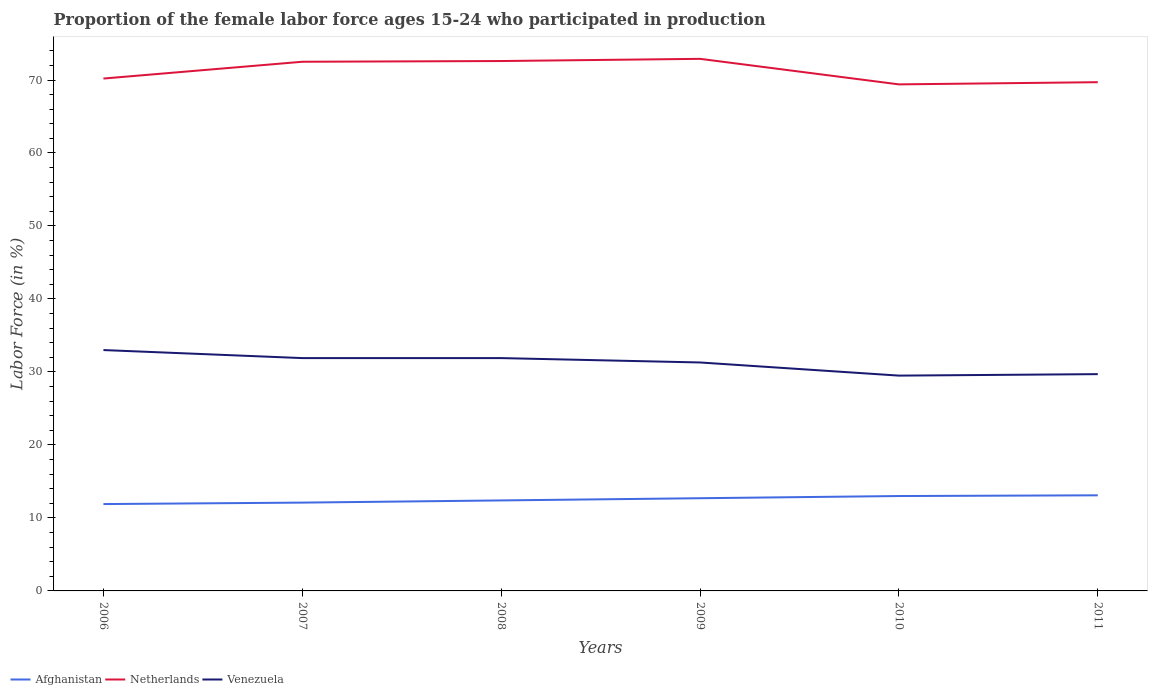Does the line corresponding to Netherlands intersect with the line corresponding to Afghanistan?
Give a very brief answer. No. Is the number of lines equal to the number of legend labels?
Offer a terse response. Yes. Across all years, what is the maximum proportion of the female labor force who participated in production in Venezuela?
Ensure brevity in your answer.  29.5. In which year was the proportion of the female labor force who participated in production in Netherlands maximum?
Offer a terse response. 2010. What is the total proportion of the female labor force who participated in production in Venezuela in the graph?
Your answer should be compact. 3.3. What is the difference between the highest and the second highest proportion of the female labor force who participated in production in Afghanistan?
Your answer should be very brief. 1.2. What is the difference between the highest and the lowest proportion of the female labor force who participated in production in Venezuela?
Your answer should be very brief. 4. How many lines are there?
Your response must be concise. 3. What is the difference between two consecutive major ticks on the Y-axis?
Make the answer very short. 10. Are the values on the major ticks of Y-axis written in scientific E-notation?
Offer a very short reply. No. What is the title of the graph?
Provide a succinct answer. Proportion of the female labor force ages 15-24 who participated in production. Does "Dominica" appear as one of the legend labels in the graph?
Make the answer very short. No. What is the Labor Force (in %) in Afghanistan in 2006?
Ensure brevity in your answer.  11.9. What is the Labor Force (in %) in Netherlands in 2006?
Offer a terse response. 70.2. What is the Labor Force (in %) of Afghanistan in 2007?
Your response must be concise. 12.1. What is the Labor Force (in %) of Netherlands in 2007?
Your answer should be compact. 72.5. What is the Labor Force (in %) in Venezuela in 2007?
Ensure brevity in your answer.  31.9. What is the Labor Force (in %) in Afghanistan in 2008?
Offer a terse response. 12.4. What is the Labor Force (in %) in Netherlands in 2008?
Make the answer very short. 72.6. What is the Labor Force (in %) of Venezuela in 2008?
Give a very brief answer. 31.9. What is the Labor Force (in %) of Afghanistan in 2009?
Keep it short and to the point. 12.7. What is the Labor Force (in %) in Netherlands in 2009?
Offer a terse response. 72.9. What is the Labor Force (in %) in Venezuela in 2009?
Your answer should be compact. 31.3. What is the Labor Force (in %) in Netherlands in 2010?
Your answer should be compact. 69.4. What is the Labor Force (in %) in Venezuela in 2010?
Your answer should be compact. 29.5. What is the Labor Force (in %) of Afghanistan in 2011?
Your response must be concise. 13.1. What is the Labor Force (in %) in Netherlands in 2011?
Keep it short and to the point. 69.7. What is the Labor Force (in %) of Venezuela in 2011?
Ensure brevity in your answer.  29.7. Across all years, what is the maximum Labor Force (in %) in Afghanistan?
Offer a very short reply. 13.1. Across all years, what is the maximum Labor Force (in %) in Netherlands?
Offer a terse response. 72.9. Across all years, what is the minimum Labor Force (in %) of Afghanistan?
Your response must be concise. 11.9. Across all years, what is the minimum Labor Force (in %) of Netherlands?
Make the answer very short. 69.4. Across all years, what is the minimum Labor Force (in %) in Venezuela?
Provide a succinct answer. 29.5. What is the total Labor Force (in %) of Afghanistan in the graph?
Provide a succinct answer. 75.2. What is the total Labor Force (in %) in Netherlands in the graph?
Give a very brief answer. 427.3. What is the total Labor Force (in %) of Venezuela in the graph?
Give a very brief answer. 187.3. What is the difference between the Labor Force (in %) in Afghanistan in 2006 and that in 2007?
Your response must be concise. -0.2. What is the difference between the Labor Force (in %) in Netherlands in 2006 and that in 2007?
Keep it short and to the point. -2.3. What is the difference between the Labor Force (in %) in Venezuela in 2006 and that in 2007?
Give a very brief answer. 1.1. What is the difference between the Labor Force (in %) of Afghanistan in 2006 and that in 2008?
Keep it short and to the point. -0.5. What is the difference between the Labor Force (in %) in Netherlands in 2006 and that in 2008?
Make the answer very short. -2.4. What is the difference between the Labor Force (in %) of Venezuela in 2006 and that in 2008?
Make the answer very short. 1.1. What is the difference between the Labor Force (in %) of Afghanistan in 2006 and that in 2009?
Provide a succinct answer. -0.8. What is the difference between the Labor Force (in %) of Netherlands in 2006 and that in 2009?
Offer a very short reply. -2.7. What is the difference between the Labor Force (in %) in Afghanistan in 2006 and that in 2010?
Your answer should be very brief. -1.1. What is the difference between the Labor Force (in %) in Afghanistan in 2006 and that in 2011?
Your response must be concise. -1.2. What is the difference between the Labor Force (in %) of Netherlands in 2007 and that in 2008?
Provide a short and direct response. -0.1. What is the difference between the Labor Force (in %) of Afghanistan in 2007 and that in 2009?
Offer a very short reply. -0.6. What is the difference between the Labor Force (in %) in Netherlands in 2007 and that in 2009?
Give a very brief answer. -0.4. What is the difference between the Labor Force (in %) in Venezuela in 2007 and that in 2009?
Ensure brevity in your answer.  0.6. What is the difference between the Labor Force (in %) in Netherlands in 2007 and that in 2010?
Ensure brevity in your answer.  3.1. What is the difference between the Labor Force (in %) of Netherlands in 2007 and that in 2011?
Ensure brevity in your answer.  2.8. What is the difference between the Labor Force (in %) in Netherlands in 2008 and that in 2010?
Your response must be concise. 3.2. What is the difference between the Labor Force (in %) of Venezuela in 2008 and that in 2010?
Offer a terse response. 2.4. What is the difference between the Labor Force (in %) in Afghanistan in 2008 and that in 2011?
Keep it short and to the point. -0.7. What is the difference between the Labor Force (in %) of Netherlands in 2008 and that in 2011?
Your answer should be very brief. 2.9. What is the difference between the Labor Force (in %) in Afghanistan in 2009 and that in 2010?
Provide a short and direct response. -0.3. What is the difference between the Labor Force (in %) in Netherlands in 2009 and that in 2011?
Your answer should be very brief. 3.2. What is the difference between the Labor Force (in %) of Venezuela in 2009 and that in 2011?
Give a very brief answer. 1.6. What is the difference between the Labor Force (in %) in Afghanistan in 2010 and that in 2011?
Offer a very short reply. -0.1. What is the difference between the Labor Force (in %) of Afghanistan in 2006 and the Labor Force (in %) of Netherlands in 2007?
Your answer should be compact. -60.6. What is the difference between the Labor Force (in %) of Afghanistan in 2006 and the Labor Force (in %) of Venezuela in 2007?
Your response must be concise. -20. What is the difference between the Labor Force (in %) of Netherlands in 2006 and the Labor Force (in %) of Venezuela in 2007?
Offer a very short reply. 38.3. What is the difference between the Labor Force (in %) in Afghanistan in 2006 and the Labor Force (in %) in Netherlands in 2008?
Give a very brief answer. -60.7. What is the difference between the Labor Force (in %) of Netherlands in 2006 and the Labor Force (in %) of Venezuela in 2008?
Offer a very short reply. 38.3. What is the difference between the Labor Force (in %) of Afghanistan in 2006 and the Labor Force (in %) of Netherlands in 2009?
Make the answer very short. -61. What is the difference between the Labor Force (in %) in Afghanistan in 2006 and the Labor Force (in %) in Venezuela in 2009?
Your response must be concise. -19.4. What is the difference between the Labor Force (in %) of Netherlands in 2006 and the Labor Force (in %) of Venezuela in 2009?
Offer a terse response. 38.9. What is the difference between the Labor Force (in %) of Afghanistan in 2006 and the Labor Force (in %) of Netherlands in 2010?
Keep it short and to the point. -57.5. What is the difference between the Labor Force (in %) in Afghanistan in 2006 and the Labor Force (in %) in Venezuela in 2010?
Make the answer very short. -17.6. What is the difference between the Labor Force (in %) in Netherlands in 2006 and the Labor Force (in %) in Venezuela in 2010?
Offer a very short reply. 40.7. What is the difference between the Labor Force (in %) in Afghanistan in 2006 and the Labor Force (in %) in Netherlands in 2011?
Offer a very short reply. -57.8. What is the difference between the Labor Force (in %) in Afghanistan in 2006 and the Labor Force (in %) in Venezuela in 2011?
Make the answer very short. -17.8. What is the difference between the Labor Force (in %) in Netherlands in 2006 and the Labor Force (in %) in Venezuela in 2011?
Your response must be concise. 40.5. What is the difference between the Labor Force (in %) of Afghanistan in 2007 and the Labor Force (in %) of Netherlands in 2008?
Keep it short and to the point. -60.5. What is the difference between the Labor Force (in %) of Afghanistan in 2007 and the Labor Force (in %) of Venezuela in 2008?
Your answer should be compact. -19.8. What is the difference between the Labor Force (in %) in Netherlands in 2007 and the Labor Force (in %) in Venezuela in 2008?
Your answer should be compact. 40.6. What is the difference between the Labor Force (in %) of Afghanistan in 2007 and the Labor Force (in %) of Netherlands in 2009?
Offer a very short reply. -60.8. What is the difference between the Labor Force (in %) of Afghanistan in 2007 and the Labor Force (in %) of Venezuela in 2009?
Give a very brief answer. -19.2. What is the difference between the Labor Force (in %) of Netherlands in 2007 and the Labor Force (in %) of Venezuela in 2009?
Your answer should be very brief. 41.2. What is the difference between the Labor Force (in %) of Afghanistan in 2007 and the Labor Force (in %) of Netherlands in 2010?
Your response must be concise. -57.3. What is the difference between the Labor Force (in %) in Afghanistan in 2007 and the Labor Force (in %) in Venezuela in 2010?
Your answer should be very brief. -17.4. What is the difference between the Labor Force (in %) of Netherlands in 2007 and the Labor Force (in %) of Venezuela in 2010?
Offer a very short reply. 43. What is the difference between the Labor Force (in %) of Afghanistan in 2007 and the Labor Force (in %) of Netherlands in 2011?
Your response must be concise. -57.6. What is the difference between the Labor Force (in %) in Afghanistan in 2007 and the Labor Force (in %) in Venezuela in 2011?
Your response must be concise. -17.6. What is the difference between the Labor Force (in %) in Netherlands in 2007 and the Labor Force (in %) in Venezuela in 2011?
Your answer should be very brief. 42.8. What is the difference between the Labor Force (in %) in Afghanistan in 2008 and the Labor Force (in %) in Netherlands in 2009?
Ensure brevity in your answer.  -60.5. What is the difference between the Labor Force (in %) in Afghanistan in 2008 and the Labor Force (in %) in Venezuela in 2009?
Your response must be concise. -18.9. What is the difference between the Labor Force (in %) of Netherlands in 2008 and the Labor Force (in %) of Venezuela in 2009?
Ensure brevity in your answer.  41.3. What is the difference between the Labor Force (in %) in Afghanistan in 2008 and the Labor Force (in %) in Netherlands in 2010?
Keep it short and to the point. -57. What is the difference between the Labor Force (in %) in Afghanistan in 2008 and the Labor Force (in %) in Venezuela in 2010?
Give a very brief answer. -17.1. What is the difference between the Labor Force (in %) in Netherlands in 2008 and the Labor Force (in %) in Venezuela in 2010?
Keep it short and to the point. 43.1. What is the difference between the Labor Force (in %) in Afghanistan in 2008 and the Labor Force (in %) in Netherlands in 2011?
Provide a short and direct response. -57.3. What is the difference between the Labor Force (in %) in Afghanistan in 2008 and the Labor Force (in %) in Venezuela in 2011?
Keep it short and to the point. -17.3. What is the difference between the Labor Force (in %) of Netherlands in 2008 and the Labor Force (in %) of Venezuela in 2011?
Make the answer very short. 42.9. What is the difference between the Labor Force (in %) of Afghanistan in 2009 and the Labor Force (in %) of Netherlands in 2010?
Your answer should be very brief. -56.7. What is the difference between the Labor Force (in %) in Afghanistan in 2009 and the Labor Force (in %) in Venezuela in 2010?
Your answer should be very brief. -16.8. What is the difference between the Labor Force (in %) in Netherlands in 2009 and the Labor Force (in %) in Venezuela in 2010?
Your answer should be very brief. 43.4. What is the difference between the Labor Force (in %) in Afghanistan in 2009 and the Labor Force (in %) in Netherlands in 2011?
Give a very brief answer. -57. What is the difference between the Labor Force (in %) in Netherlands in 2009 and the Labor Force (in %) in Venezuela in 2011?
Give a very brief answer. 43.2. What is the difference between the Labor Force (in %) in Afghanistan in 2010 and the Labor Force (in %) in Netherlands in 2011?
Offer a very short reply. -56.7. What is the difference between the Labor Force (in %) in Afghanistan in 2010 and the Labor Force (in %) in Venezuela in 2011?
Keep it short and to the point. -16.7. What is the difference between the Labor Force (in %) in Netherlands in 2010 and the Labor Force (in %) in Venezuela in 2011?
Your answer should be compact. 39.7. What is the average Labor Force (in %) of Afghanistan per year?
Offer a terse response. 12.53. What is the average Labor Force (in %) of Netherlands per year?
Provide a succinct answer. 71.22. What is the average Labor Force (in %) in Venezuela per year?
Offer a very short reply. 31.22. In the year 2006, what is the difference between the Labor Force (in %) of Afghanistan and Labor Force (in %) of Netherlands?
Keep it short and to the point. -58.3. In the year 2006, what is the difference between the Labor Force (in %) in Afghanistan and Labor Force (in %) in Venezuela?
Your answer should be compact. -21.1. In the year 2006, what is the difference between the Labor Force (in %) in Netherlands and Labor Force (in %) in Venezuela?
Your answer should be compact. 37.2. In the year 2007, what is the difference between the Labor Force (in %) in Afghanistan and Labor Force (in %) in Netherlands?
Make the answer very short. -60.4. In the year 2007, what is the difference between the Labor Force (in %) of Afghanistan and Labor Force (in %) of Venezuela?
Offer a terse response. -19.8. In the year 2007, what is the difference between the Labor Force (in %) of Netherlands and Labor Force (in %) of Venezuela?
Ensure brevity in your answer.  40.6. In the year 2008, what is the difference between the Labor Force (in %) of Afghanistan and Labor Force (in %) of Netherlands?
Provide a succinct answer. -60.2. In the year 2008, what is the difference between the Labor Force (in %) of Afghanistan and Labor Force (in %) of Venezuela?
Offer a terse response. -19.5. In the year 2008, what is the difference between the Labor Force (in %) of Netherlands and Labor Force (in %) of Venezuela?
Your response must be concise. 40.7. In the year 2009, what is the difference between the Labor Force (in %) in Afghanistan and Labor Force (in %) in Netherlands?
Your answer should be compact. -60.2. In the year 2009, what is the difference between the Labor Force (in %) in Afghanistan and Labor Force (in %) in Venezuela?
Your answer should be compact. -18.6. In the year 2009, what is the difference between the Labor Force (in %) in Netherlands and Labor Force (in %) in Venezuela?
Your answer should be very brief. 41.6. In the year 2010, what is the difference between the Labor Force (in %) of Afghanistan and Labor Force (in %) of Netherlands?
Offer a very short reply. -56.4. In the year 2010, what is the difference between the Labor Force (in %) in Afghanistan and Labor Force (in %) in Venezuela?
Provide a short and direct response. -16.5. In the year 2010, what is the difference between the Labor Force (in %) of Netherlands and Labor Force (in %) of Venezuela?
Your answer should be compact. 39.9. In the year 2011, what is the difference between the Labor Force (in %) of Afghanistan and Labor Force (in %) of Netherlands?
Your answer should be very brief. -56.6. In the year 2011, what is the difference between the Labor Force (in %) in Afghanistan and Labor Force (in %) in Venezuela?
Provide a succinct answer. -16.6. In the year 2011, what is the difference between the Labor Force (in %) of Netherlands and Labor Force (in %) of Venezuela?
Provide a short and direct response. 40. What is the ratio of the Labor Force (in %) in Afghanistan in 2006 to that in 2007?
Provide a succinct answer. 0.98. What is the ratio of the Labor Force (in %) in Netherlands in 2006 to that in 2007?
Provide a succinct answer. 0.97. What is the ratio of the Labor Force (in %) of Venezuela in 2006 to that in 2007?
Provide a short and direct response. 1.03. What is the ratio of the Labor Force (in %) of Afghanistan in 2006 to that in 2008?
Keep it short and to the point. 0.96. What is the ratio of the Labor Force (in %) in Netherlands in 2006 to that in 2008?
Give a very brief answer. 0.97. What is the ratio of the Labor Force (in %) in Venezuela in 2006 to that in 2008?
Provide a short and direct response. 1.03. What is the ratio of the Labor Force (in %) of Afghanistan in 2006 to that in 2009?
Your answer should be very brief. 0.94. What is the ratio of the Labor Force (in %) in Netherlands in 2006 to that in 2009?
Offer a terse response. 0.96. What is the ratio of the Labor Force (in %) of Venezuela in 2006 to that in 2009?
Your answer should be compact. 1.05. What is the ratio of the Labor Force (in %) in Afghanistan in 2006 to that in 2010?
Your answer should be compact. 0.92. What is the ratio of the Labor Force (in %) in Netherlands in 2006 to that in 2010?
Provide a short and direct response. 1.01. What is the ratio of the Labor Force (in %) of Venezuela in 2006 to that in 2010?
Your response must be concise. 1.12. What is the ratio of the Labor Force (in %) in Afghanistan in 2006 to that in 2011?
Your answer should be very brief. 0.91. What is the ratio of the Labor Force (in %) of Netherlands in 2006 to that in 2011?
Provide a succinct answer. 1.01. What is the ratio of the Labor Force (in %) in Afghanistan in 2007 to that in 2008?
Offer a very short reply. 0.98. What is the ratio of the Labor Force (in %) in Afghanistan in 2007 to that in 2009?
Provide a succinct answer. 0.95. What is the ratio of the Labor Force (in %) in Netherlands in 2007 to that in 2009?
Provide a succinct answer. 0.99. What is the ratio of the Labor Force (in %) in Venezuela in 2007 to that in 2009?
Your answer should be compact. 1.02. What is the ratio of the Labor Force (in %) of Afghanistan in 2007 to that in 2010?
Offer a very short reply. 0.93. What is the ratio of the Labor Force (in %) of Netherlands in 2007 to that in 2010?
Offer a terse response. 1.04. What is the ratio of the Labor Force (in %) in Venezuela in 2007 to that in 2010?
Your answer should be compact. 1.08. What is the ratio of the Labor Force (in %) of Afghanistan in 2007 to that in 2011?
Provide a short and direct response. 0.92. What is the ratio of the Labor Force (in %) in Netherlands in 2007 to that in 2011?
Your response must be concise. 1.04. What is the ratio of the Labor Force (in %) in Venezuela in 2007 to that in 2011?
Make the answer very short. 1.07. What is the ratio of the Labor Force (in %) of Afghanistan in 2008 to that in 2009?
Your answer should be very brief. 0.98. What is the ratio of the Labor Force (in %) in Venezuela in 2008 to that in 2009?
Your answer should be very brief. 1.02. What is the ratio of the Labor Force (in %) of Afghanistan in 2008 to that in 2010?
Make the answer very short. 0.95. What is the ratio of the Labor Force (in %) of Netherlands in 2008 to that in 2010?
Your answer should be compact. 1.05. What is the ratio of the Labor Force (in %) in Venezuela in 2008 to that in 2010?
Make the answer very short. 1.08. What is the ratio of the Labor Force (in %) in Afghanistan in 2008 to that in 2011?
Offer a very short reply. 0.95. What is the ratio of the Labor Force (in %) in Netherlands in 2008 to that in 2011?
Provide a short and direct response. 1.04. What is the ratio of the Labor Force (in %) of Venezuela in 2008 to that in 2011?
Your response must be concise. 1.07. What is the ratio of the Labor Force (in %) of Afghanistan in 2009 to that in 2010?
Provide a short and direct response. 0.98. What is the ratio of the Labor Force (in %) in Netherlands in 2009 to that in 2010?
Ensure brevity in your answer.  1.05. What is the ratio of the Labor Force (in %) of Venezuela in 2009 to that in 2010?
Provide a succinct answer. 1.06. What is the ratio of the Labor Force (in %) of Afghanistan in 2009 to that in 2011?
Your answer should be compact. 0.97. What is the ratio of the Labor Force (in %) of Netherlands in 2009 to that in 2011?
Give a very brief answer. 1.05. What is the ratio of the Labor Force (in %) in Venezuela in 2009 to that in 2011?
Offer a very short reply. 1.05. What is the ratio of the Labor Force (in %) in Netherlands in 2010 to that in 2011?
Offer a very short reply. 1. What is the difference between the highest and the second highest Labor Force (in %) of Afghanistan?
Provide a succinct answer. 0.1. What is the difference between the highest and the lowest Labor Force (in %) in Netherlands?
Offer a very short reply. 3.5. What is the difference between the highest and the lowest Labor Force (in %) of Venezuela?
Make the answer very short. 3.5. 